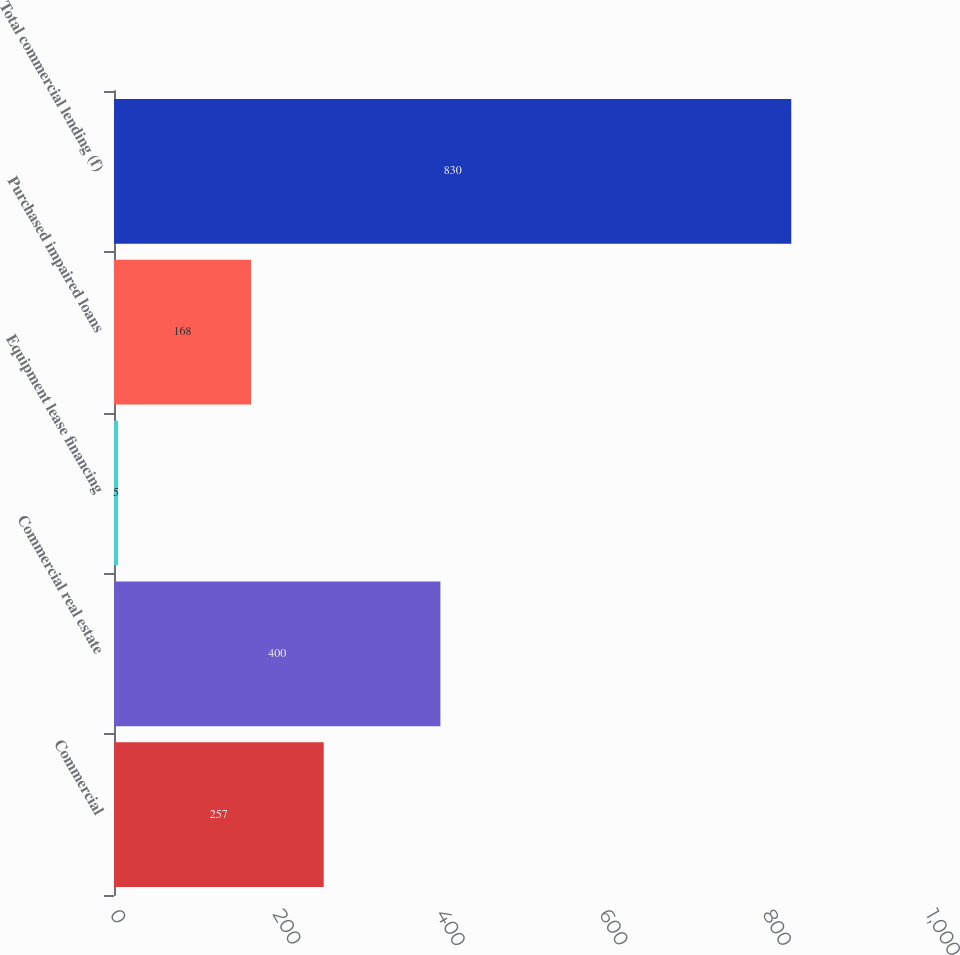<chart> <loc_0><loc_0><loc_500><loc_500><bar_chart><fcel>Commercial<fcel>Commercial real estate<fcel>Equipment lease financing<fcel>Purchased impaired loans<fcel>Total commercial lending (f)<nl><fcel>257<fcel>400<fcel>5<fcel>168<fcel>830<nl></chart> 